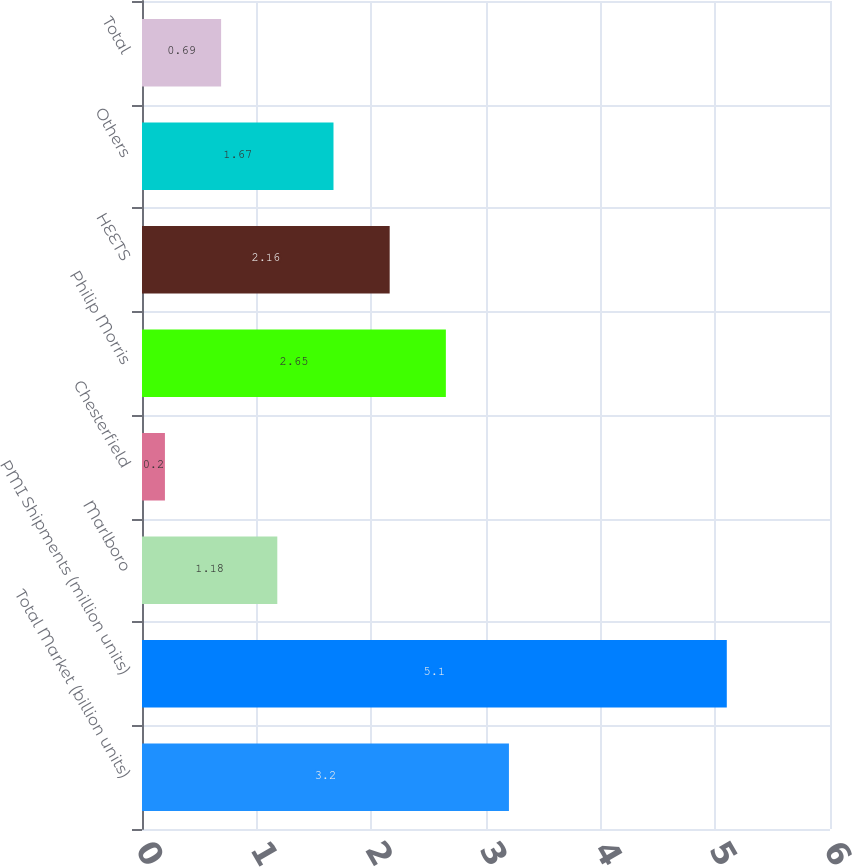Convert chart. <chart><loc_0><loc_0><loc_500><loc_500><bar_chart><fcel>Total Market (billion units)<fcel>PMI Shipments (million units)<fcel>Marlboro<fcel>Chesterfield<fcel>Philip Morris<fcel>HEETS<fcel>Others<fcel>Total<nl><fcel>3.2<fcel>5.1<fcel>1.18<fcel>0.2<fcel>2.65<fcel>2.16<fcel>1.67<fcel>0.69<nl></chart> 